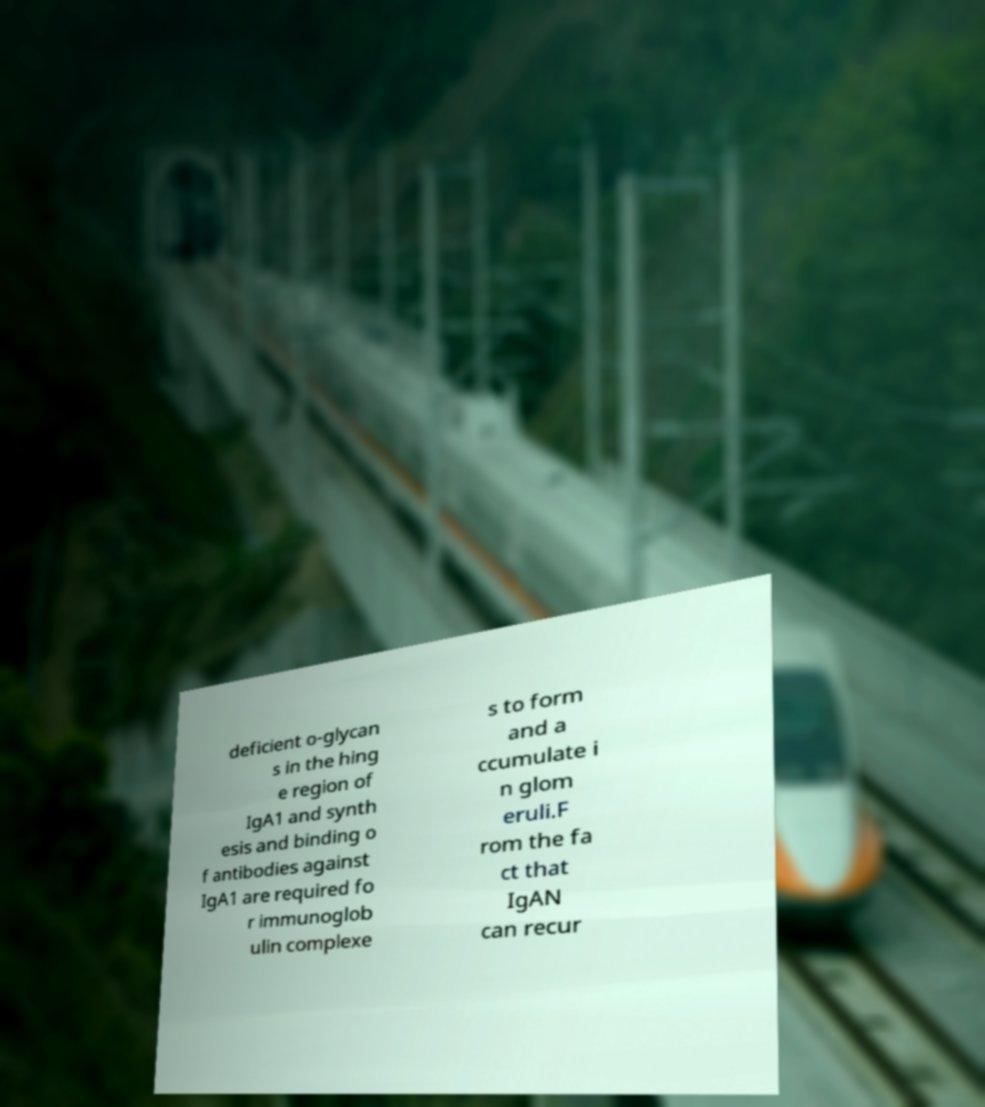Please read and relay the text visible in this image. What does it say? deficient o-glycan s in the hing e region of IgA1 and synth esis and binding o f antibodies against IgA1 are required fo r immunoglob ulin complexe s to form and a ccumulate i n glom eruli.F rom the fa ct that IgAN can recur 